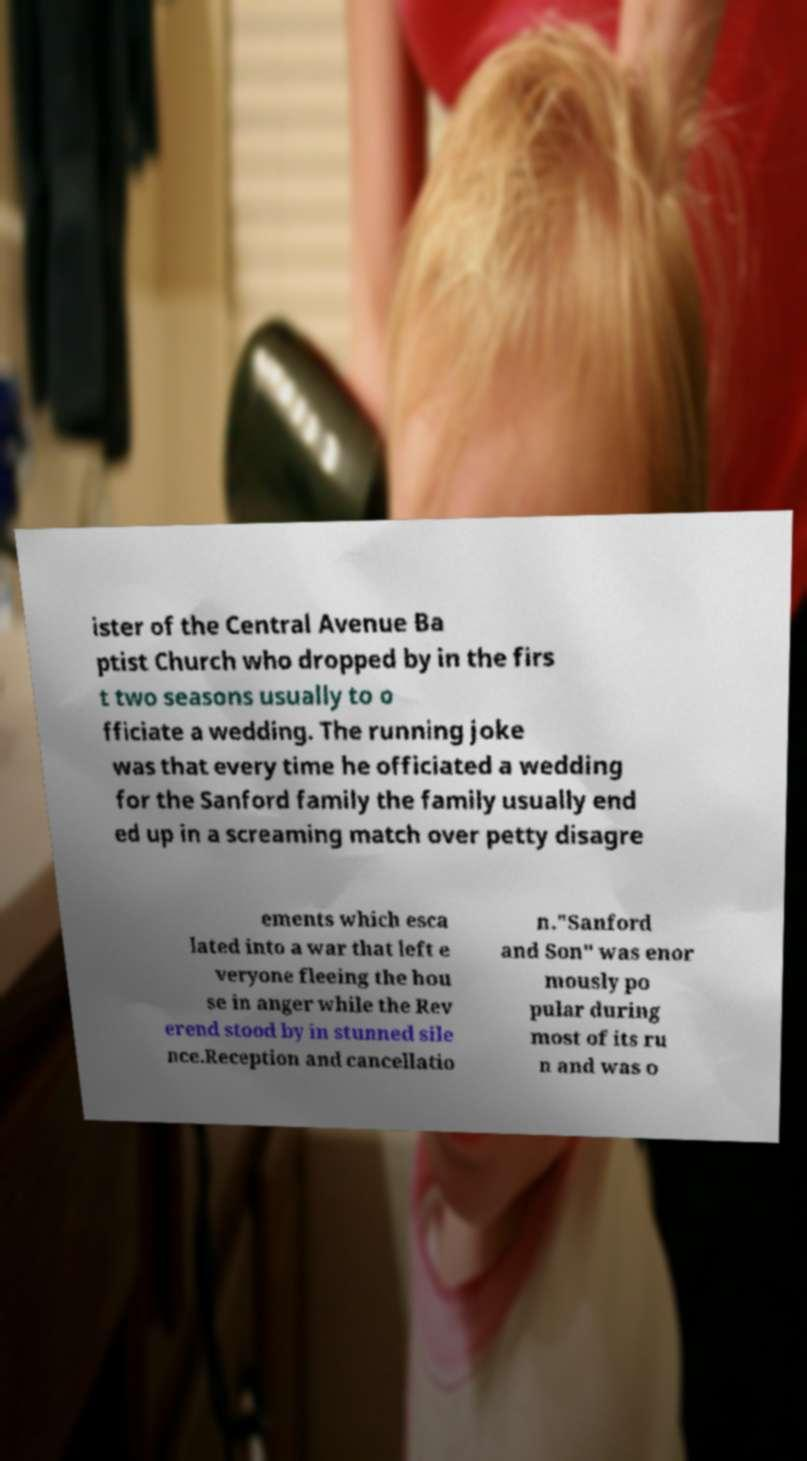Could you extract and type out the text from this image? ister of the Central Avenue Ba ptist Church who dropped by in the firs t two seasons usually to o fficiate a wedding. The running joke was that every time he officiated a wedding for the Sanford family the family usually end ed up in a screaming match over petty disagre ements which esca lated into a war that left e veryone fleeing the hou se in anger while the Rev erend stood by in stunned sile nce.Reception and cancellatio n."Sanford and Son" was enor mously po pular during most of its ru n and was o 